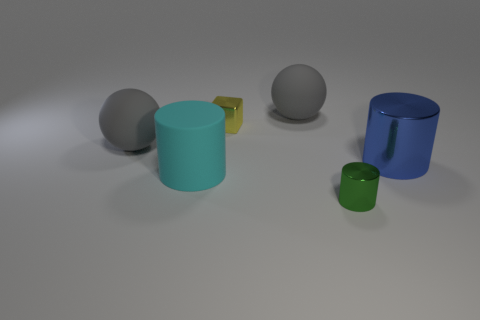Add 1 cyan objects. How many objects exist? 7 Subtract all spheres. How many objects are left? 4 Add 6 small green things. How many small green things exist? 7 Subtract 1 yellow cubes. How many objects are left? 5 Subtract all matte things. Subtract all green cylinders. How many objects are left? 2 Add 6 large gray rubber objects. How many large gray rubber objects are left? 8 